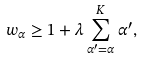<formula> <loc_0><loc_0><loc_500><loc_500>w _ { \alpha } \geq 1 + \lambda \sum _ { \alpha ^ { \prime } = \alpha } ^ { K } \alpha ^ { \prime } ,</formula> 